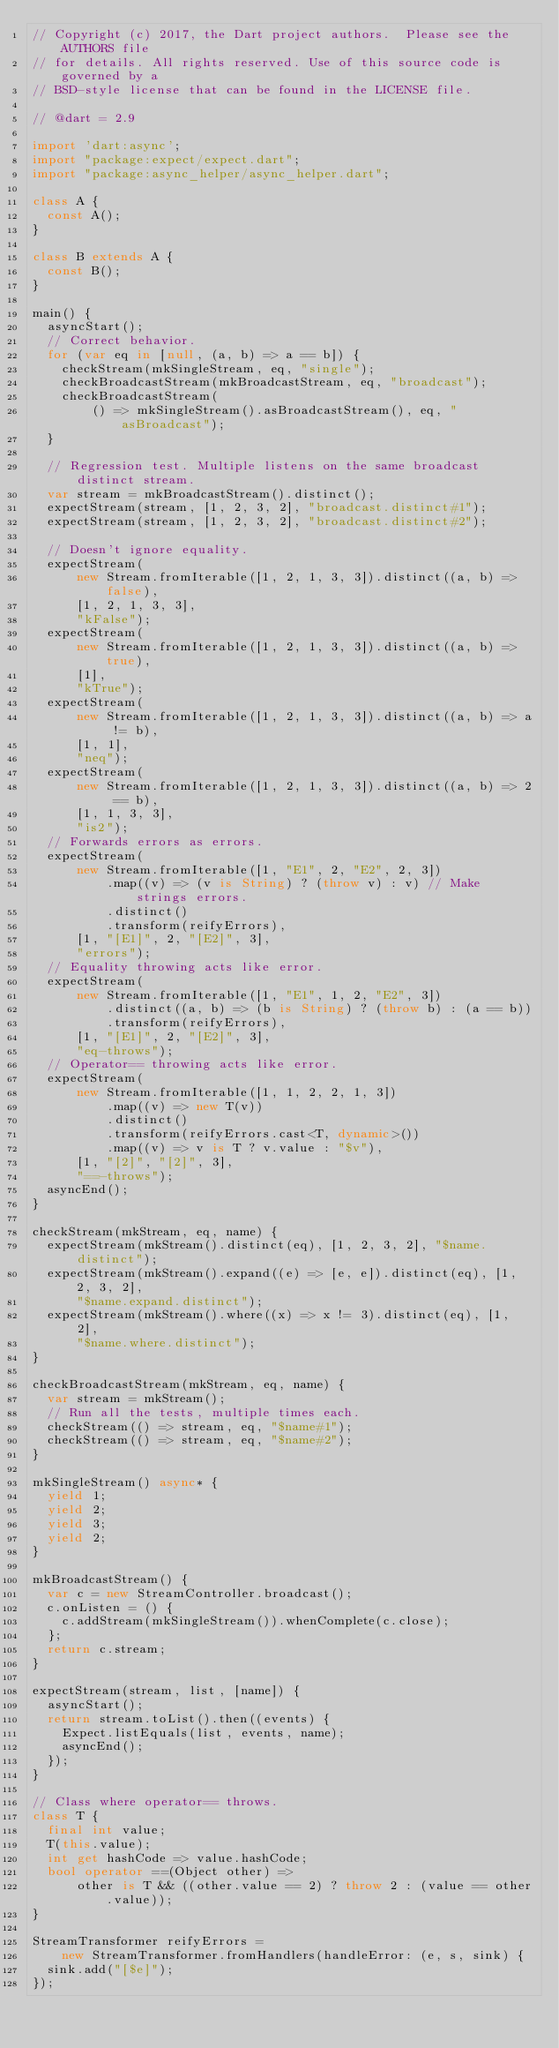Convert code to text. <code><loc_0><loc_0><loc_500><loc_500><_Dart_>// Copyright (c) 2017, the Dart project authors.  Please see the AUTHORS file
// for details. All rights reserved. Use of this source code is governed by a
// BSD-style license that can be found in the LICENSE file.

// @dart = 2.9

import 'dart:async';
import "package:expect/expect.dart";
import "package:async_helper/async_helper.dart";

class A {
  const A();
}

class B extends A {
  const B();
}

main() {
  asyncStart();
  // Correct behavior.
  for (var eq in [null, (a, b) => a == b]) {
    checkStream(mkSingleStream, eq, "single");
    checkBroadcastStream(mkBroadcastStream, eq, "broadcast");
    checkBroadcastStream(
        () => mkSingleStream().asBroadcastStream(), eq, "asBroadcast");
  }

  // Regression test. Multiple listens on the same broadcast distinct stream.
  var stream = mkBroadcastStream().distinct();
  expectStream(stream, [1, 2, 3, 2], "broadcast.distinct#1");
  expectStream(stream, [1, 2, 3, 2], "broadcast.distinct#2");

  // Doesn't ignore equality.
  expectStream(
      new Stream.fromIterable([1, 2, 1, 3, 3]).distinct((a, b) => false),
      [1, 2, 1, 3, 3],
      "kFalse");
  expectStream(
      new Stream.fromIterable([1, 2, 1, 3, 3]).distinct((a, b) => true),
      [1],
      "kTrue");
  expectStream(
      new Stream.fromIterable([1, 2, 1, 3, 3]).distinct((a, b) => a != b),
      [1, 1],
      "neq");
  expectStream(
      new Stream.fromIterable([1, 2, 1, 3, 3]).distinct((a, b) => 2 == b),
      [1, 1, 3, 3],
      "is2");
  // Forwards errors as errors.
  expectStream(
      new Stream.fromIterable([1, "E1", 2, "E2", 2, 3])
          .map((v) => (v is String) ? (throw v) : v) // Make strings errors.
          .distinct()
          .transform(reifyErrors),
      [1, "[E1]", 2, "[E2]", 3],
      "errors");
  // Equality throwing acts like error.
  expectStream(
      new Stream.fromIterable([1, "E1", 1, 2, "E2", 3])
          .distinct((a, b) => (b is String) ? (throw b) : (a == b))
          .transform(reifyErrors),
      [1, "[E1]", 2, "[E2]", 3],
      "eq-throws");
  // Operator== throwing acts like error.
  expectStream(
      new Stream.fromIterable([1, 1, 2, 2, 1, 3])
          .map((v) => new T(v))
          .distinct()
          .transform(reifyErrors.cast<T, dynamic>())
          .map((v) => v is T ? v.value : "$v"),
      [1, "[2]", "[2]", 3],
      "==-throws");
  asyncEnd();
}

checkStream(mkStream, eq, name) {
  expectStream(mkStream().distinct(eq), [1, 2, 3, 2], "$name.distinct");
  expectStream(mkStream().expand((e) => [e, e]).distinct(eq), [1, 2, 3, 2],
      "$name.expand.distinct");
  expectStream(mkStream().where((x) => x != 3).distinct(eq), [1, 2],
      "$name.where.distinct");
}

checkBroadcastStream(mkStream, eq, name) {
  var stream = mkStream();
  // Run all the tests, multiple times each.
  checkStream(() => stream, eq, "$name#1");
  checkStream(() => stream, eq, "$name#2");
}

mkSingleStream() async* {
  yield 1;
  yield 2;
  yield 3;
  yield 2;
}

mkBroadcastStream() {
  var c = new StreamController.broadcast();
  c.onListen = () {
    c.addStream(mkSingleStream()).whenComplete(c.close);
  };
  return c.stream;
}

expectStream(stream, list, [name]) {
  asyncStart();
  return stream.toList().then((events) {
    Expect.listEquals(list, events, name);
    asyncEnd();
  });
}

// Class where operator== throws.
class T {
  final int value;
  T(this.value);
  int get hashCode => value.hashCode;
  bool operator ==(Object other) =>
      other is T && ((other.value == 2) ? throw 2 : (value == other.value));
}

StreamTransformer reifyErrors =
    new StreamTransformer.fromHandlers(handleError: (e, s, sink) {
  sink.add("[$e]");
});
</code> 